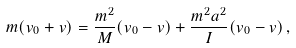Convert formula to latex. <formula><loc_0><loc_0><loc_500><loc_500>m ( v _ { 0 } + v ) = \frac { m ^ { 2 } } { M } ( v _ { 0 } - v ) + \frac { m ^ { 2 } a ^ { 2 } } { I } ( v _ { 0 } - v ) \, ,</formula> 